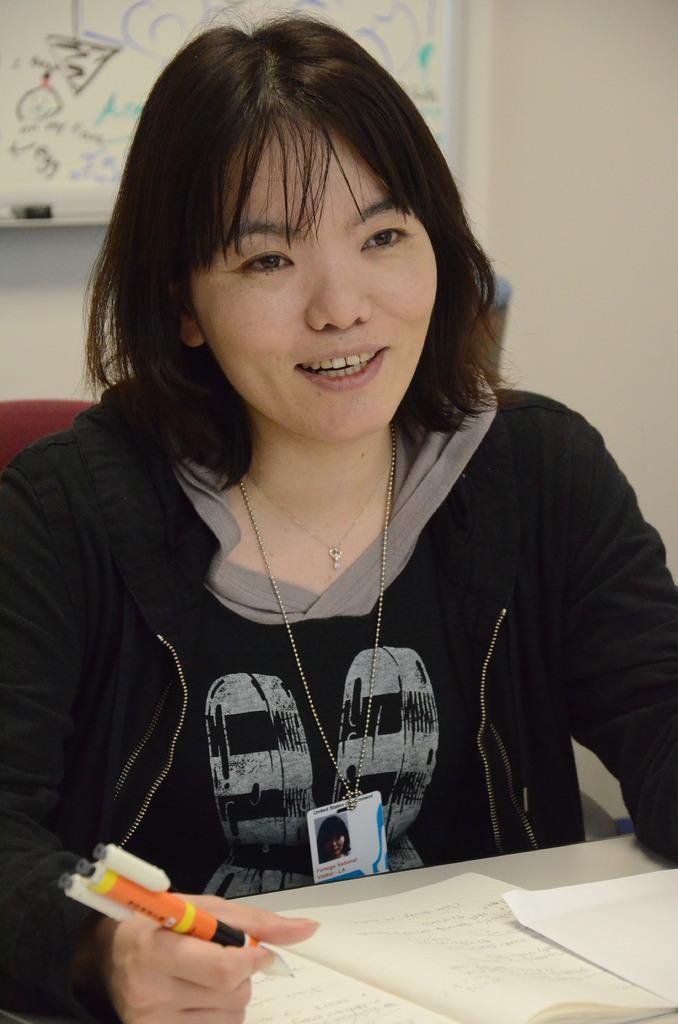What is located at the bottom of the image? There is a table at the bottom of the image. What items can be seen on the table? There is a book and a paper on the table. Can you describe the lady in the image? The lady in the image is smiling and holding a pen in her hand. What is on the wall behind the lady? There is a board on the wall. What type of insurance policy is the lady discussing with the kitty in the image? There is no kitty present in the image, and the lady is not discussing any insurance policies. 